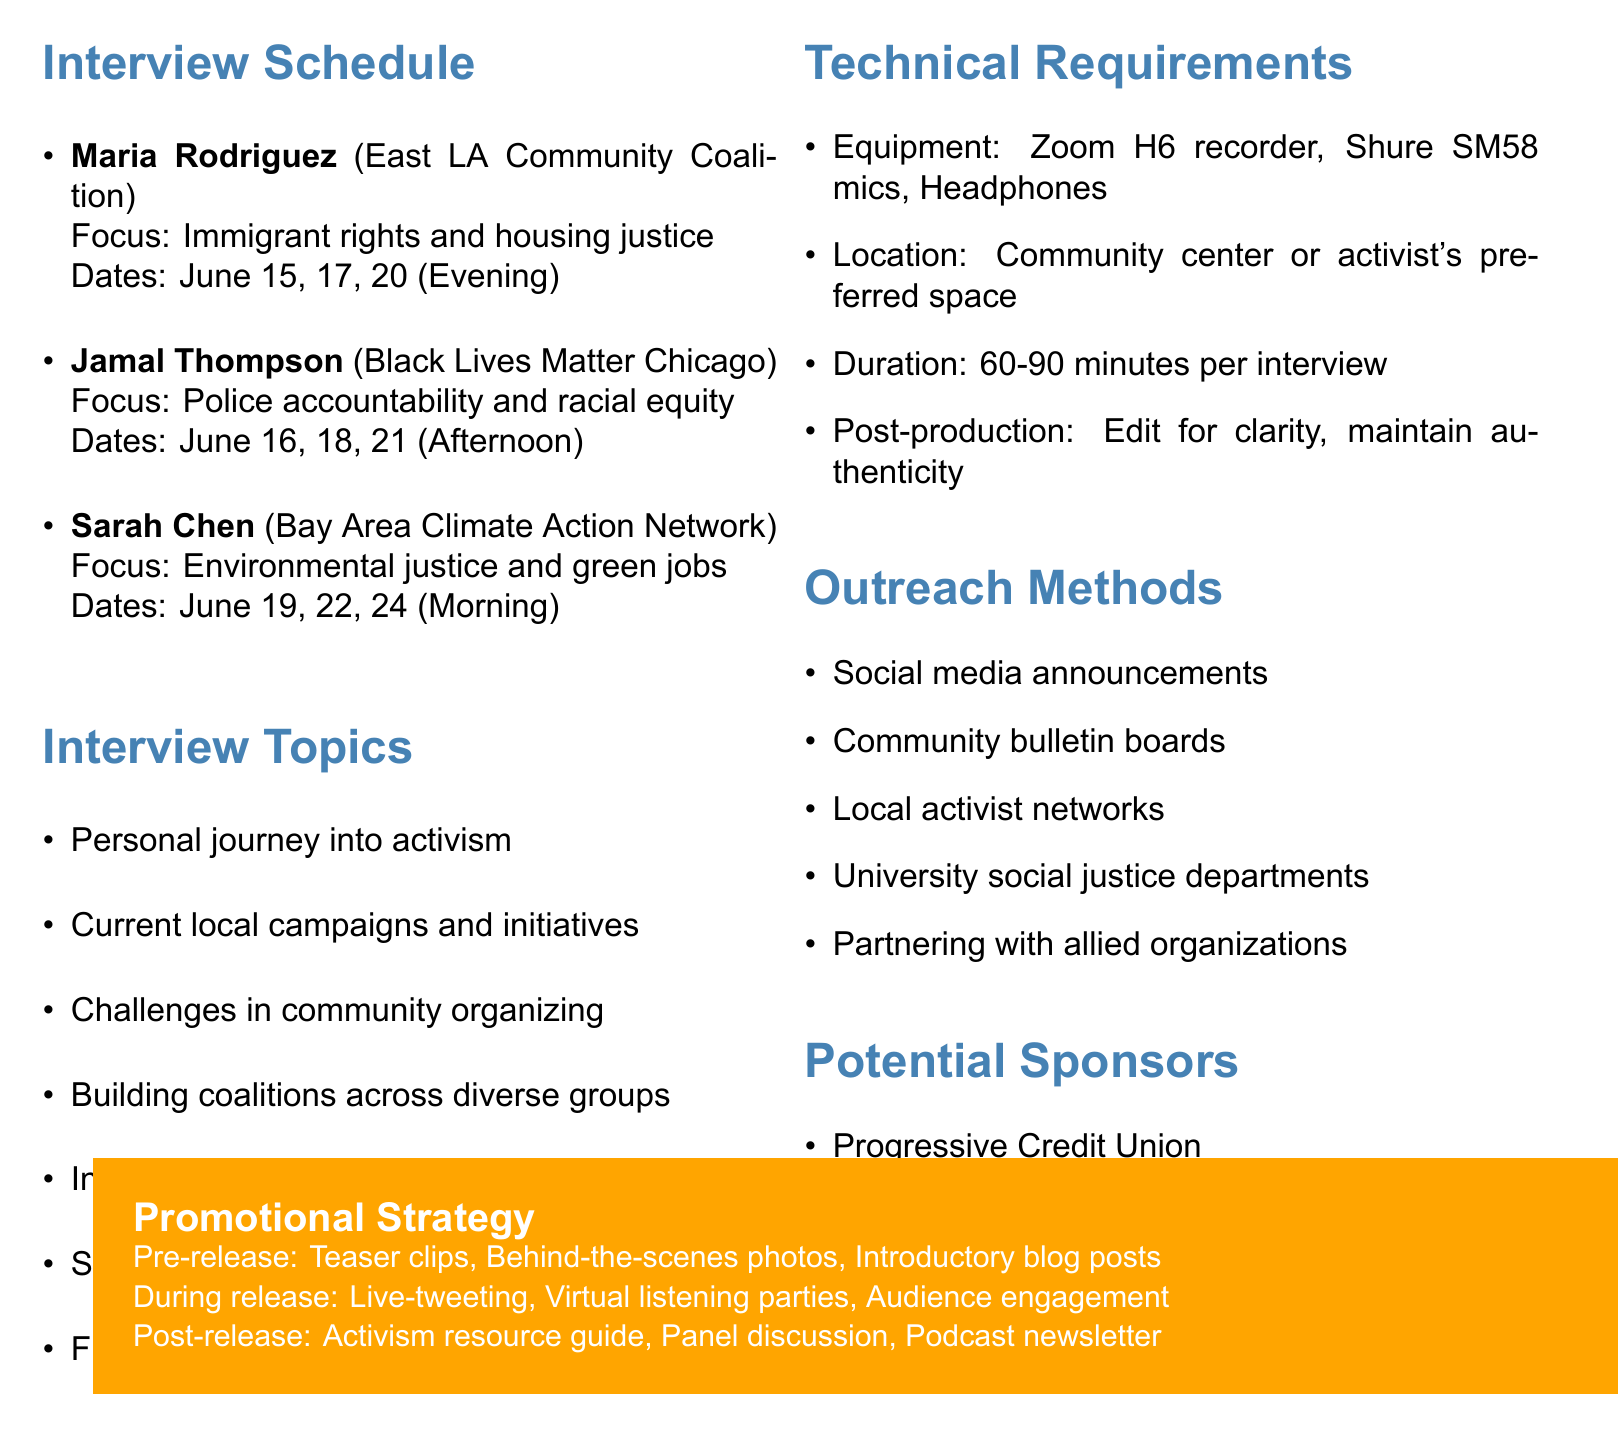What is the name of the activist from the East LA Community Coalition? The document lists Maria Rodriguez as the activist from the East LA Community Coalition.
Answer: Maria Rodriguez What dates is Jamal Thompson available for an interview? Jamal Thompson's available dates as per the document are June 16, 18, and 21.
Answer: June 16, 18, 21 What is the focus of Sarah Chen's activism? According to the document, Sarah Chen focuses on environmental justice and green jobs.
Answer: Environmental justice and green jobs What type of recording equipment is mentioned in the technical requirements? The document specifies the Zoom H6 recorder and Shure SM58 microphones in the technical requirements.
Answer: Zoom H6 recorder, Shure SM58 microphones How long is each interview scheduled to last? The document states that each interview should last between 60 to 90 minutes.
Answer: 60-90 minutes How many interview topics are listed in the document? The document contains seven distinct interview topics for discussion.
Answer: Seven What pre-release promotional strategy is mentioned? The document mentions teaser clips on Instagram and TikTok as a pre-release promotional strategy.
Answer: Teaser clips on Instagram and TikTok What is the goal of the outreach methods mentioned? The document covers outreach methods aimed at increasing community engagement and awareness for the series.
Answer: Increasing community engagement and awareness Which organization sponsors are listed? The document lists sponsors like Progressive Credit Union and Ethical Bean Coffee among others.
Answer: Progressive Credit Union, Ethical Bean Coffee 